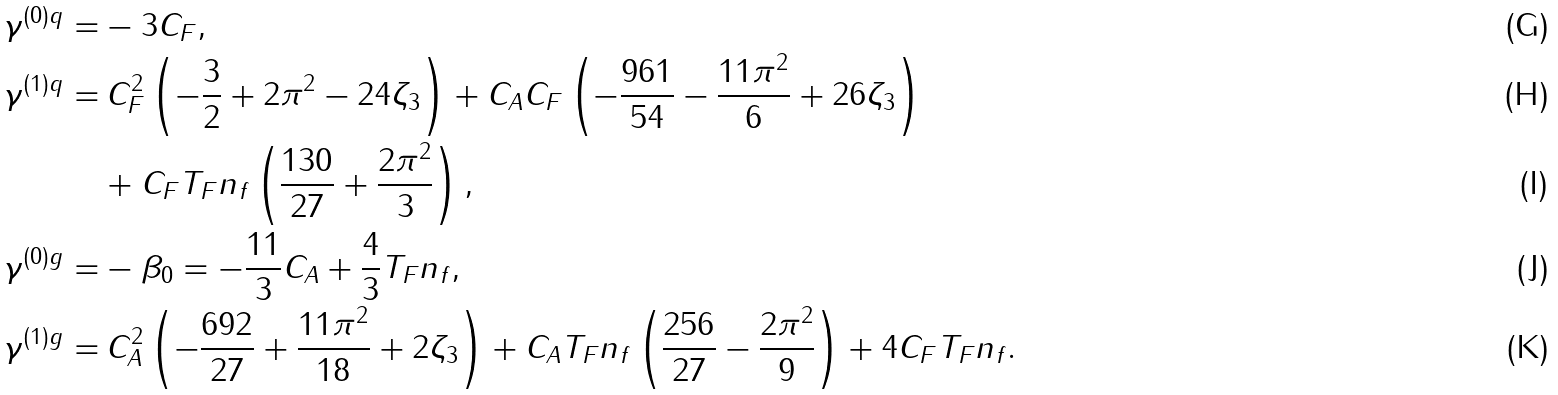<formula> <loc_0><loc_0><loc_500><loc_500>\gamma ^ { ( 0 ) q } = & - 3 C _ { F } , \\ \gamma ^ { ( 1 ) q } = & \, C _ { F } ^ { 2 } \left ( - \frac { 3 } { 2 } + 2 \pi ^ { 2 } - 2 4 \zeta _ { 3 } \right ) + C _ { A } C _ { F } \left ( - \frac { 9 6 1 } { 5 4 } - \frac { 1 1 \pi ^ { 2 } } { 6 } + 2 6 \zeta _ { 3 } \right ) \\ & + C _ { F } T _ { F } n _ { f } \left ( \frac { 1 3 0 } { 2 7 } + \frac { 2 \pi ^ { 2 } } { 3 } \right ) , \\ \gamma ^ { ( 0 ) g } = & - \beta _ { 0 } = - \frac { 1 1 } { 3 } C _ { A } + \frac { 4 } { 3 } T _ { F } n _ { f } , \\ \gamma ^ { ( 1 ) g } = & \, C _ { A } ^ { 2 } \left ( - \frac { 6 9 2 } { 2 7 } + \frac { 1 1 \pi ^ { 2 } } { 1 8 } + 2 \zeta _ { 3 } \right ) + C _ { A } T _ { F } n _ { f } \left ( \frac { 2 5 6 } { 2 7 } - \frac { 2 \pi ^ { 2 } } { 9 } \right ) + 4 C _ { F } T _ { F } n _ { f } .</formula> 